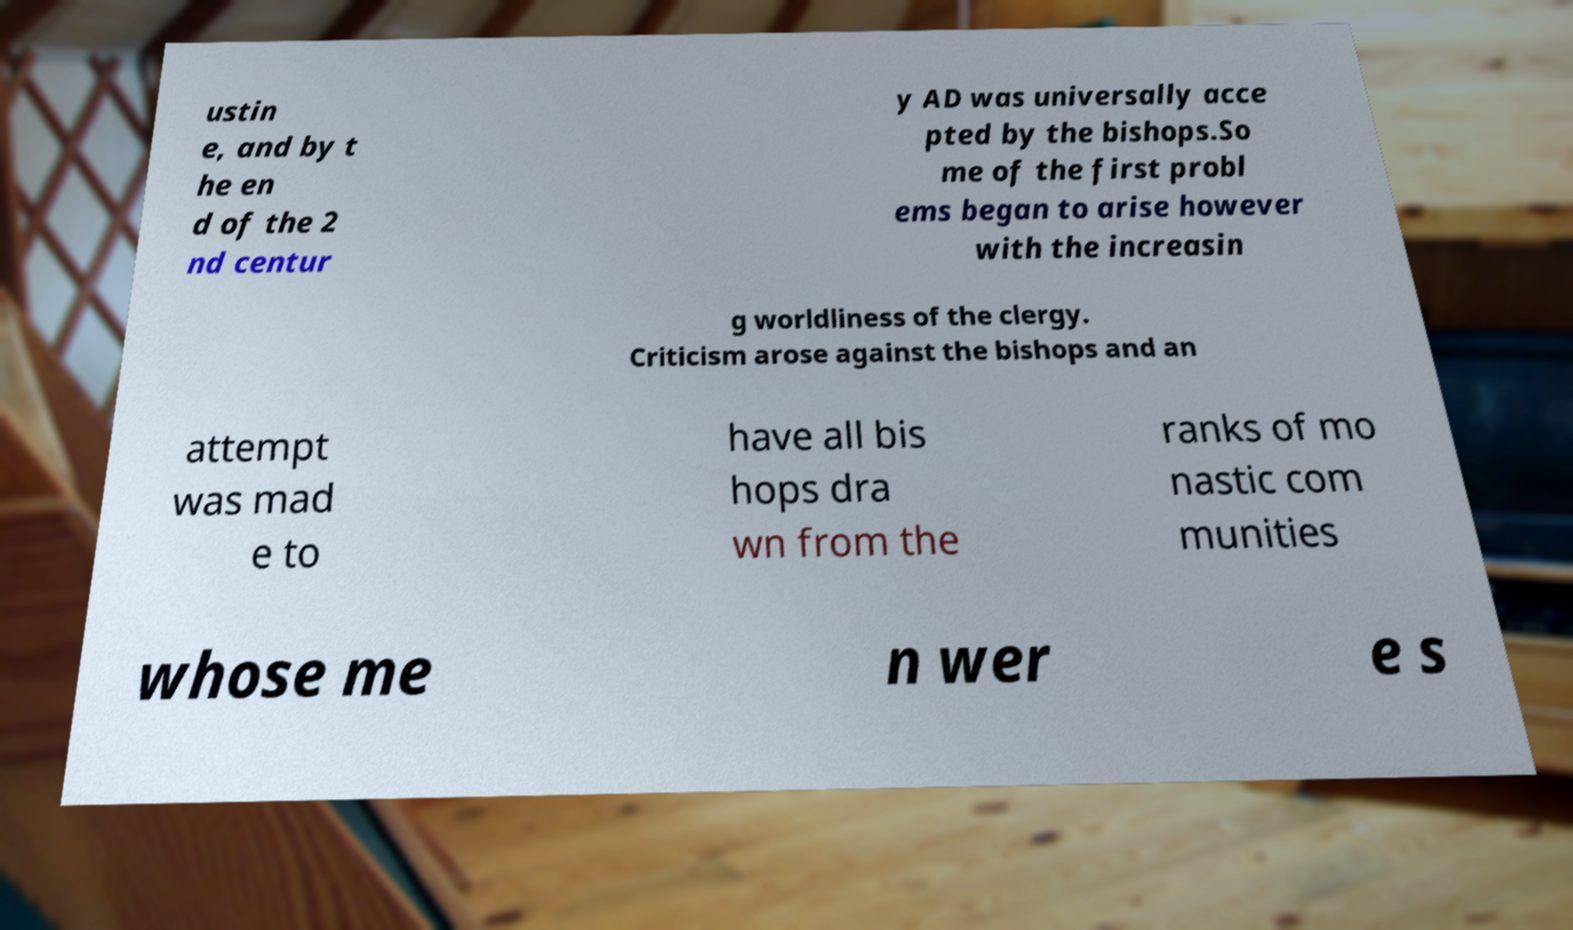Could you extract and type out the text from this image? ustin e, and by t he en d of the 2 nd centur y AD was universally acce pted by the bishops.So me of the first probl ems began to arise however with the increasin g worldliness of the clergy. Criticism arose against the bishops and an attempt was mad e to have all bis hops dra wn from the ranks of mo nastic com munities whose me n wer e s 